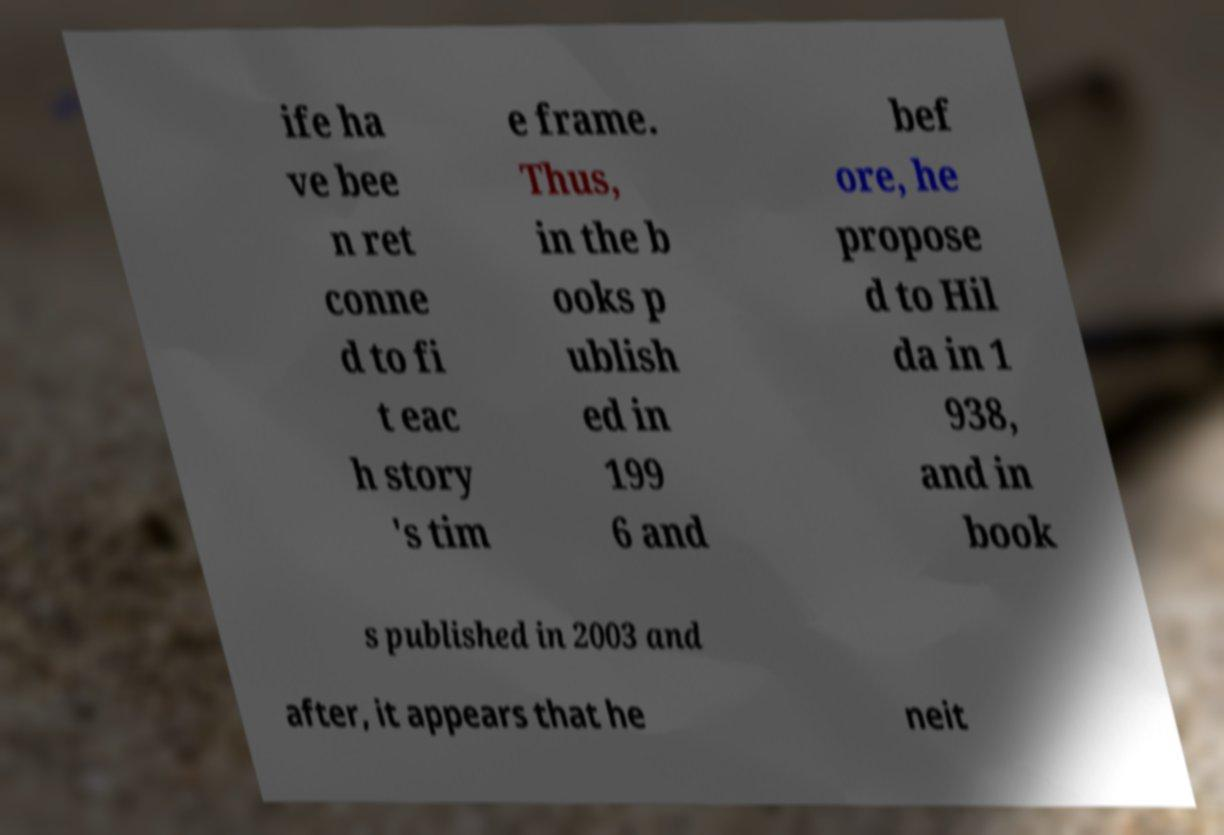Could you assist in decoding the text presented in this image and type it out clearly? ife ha ve bee n ret conne d to fi t eac h story 's tim e frame. Thus, in the b ooks p ublish ed in 199 6 and bef ore, he propose d to Hil da in 1 938, and in book s published in 2003 and after, it appears that he neit 